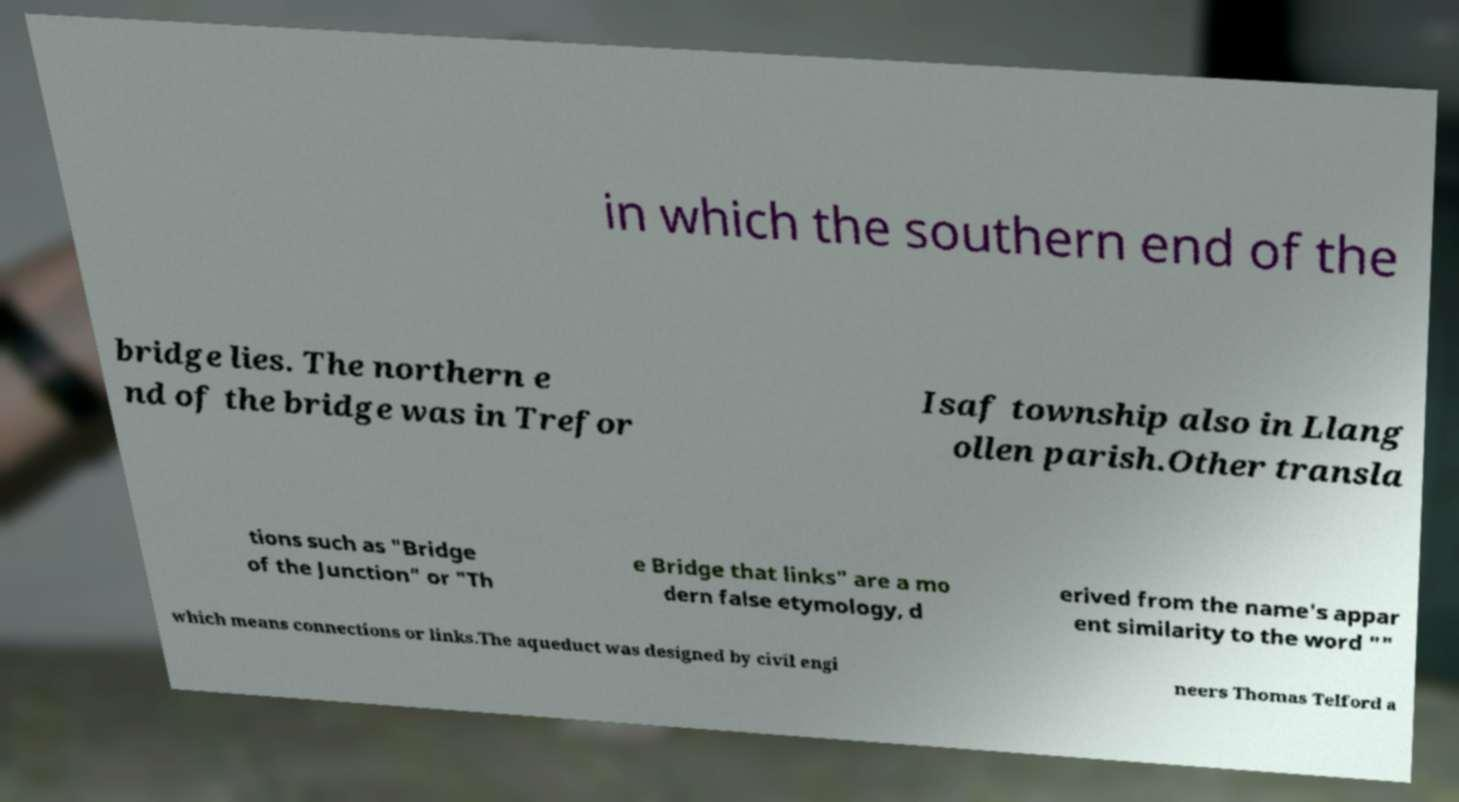Please identify and transcribe the text found in this image. in which the southern end of the bridge lies. The northern e nd of the bridge was in Trefor Isaf township also in Llang ollen parish.Other transla tions such as "Bridge of the Junction" or "Th e Bridge that links" are a mo dern false etymology, d erived from the name's appar ent similarity to the word "" which means connections or links.The aqueduct was designed by civil engi neers Thomas Telford a 